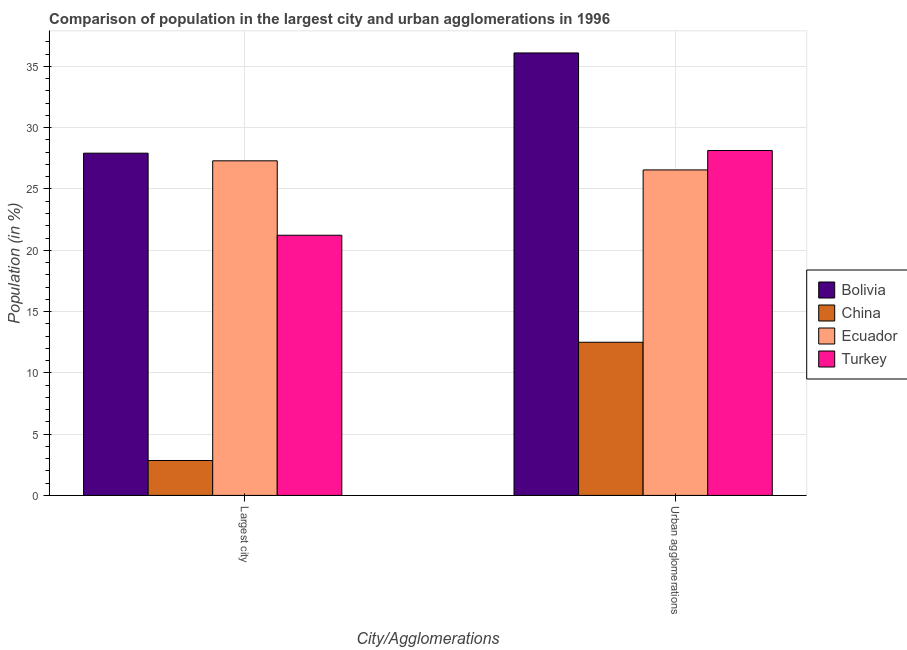How many different coloured bars are there?
Keep it short and to the point. 4. How many groups of bars are there?
Your answer should be very brief. 2. Are the number of bars on each tick of the X-axis equal?
Your answer should be very brief. Yes. How many bars are there on the 1st tick from the left?
Keep it short and to the point. 4. How many bars are there on the 1st tick from the right?
Offer a terse response. 4. What is the label of the 2nd group of bars from the left?
Your answer should be compact. Urban agglomerations. What is the population in urban agglomerations in Turkey?
Offer a terse response. 28.14. Across all countries, what is the maximum population in the largest city?
Offer a terse response. 27.92. Across all countries, what is the minimum population in urban agglomerations?
Your response must be concise. 12.5. What is the total population in the largest city in the graph?
Your answer should be compact. 79.3. What is the difference between the population in urban agglomerations in Ecuador and that in Bolivia?
Your answer should be compact. -9.54. What is the difference between the population in urban agglomerations in Bolivia and the population in the largest city in Ecuador?
Offer a very short reply. 8.8. What is the average population in urban agglomerations per country?
Your response must be concise. 25.82. What is the difference between the population in the largest city and population in urban agglomerations in Ecuador?
Your answer should be compact. 0.74. What is the ratio of the population in urban agglomerations in Turkey to that in Bolivia?
Give a very brief answer. 0.78. Is the population in the largest city in Turkey less than that in China?
Your answer should be very brief. No. What does the 1st bar from the left in Urban agglomerations represents?
Your answer should be compact. Bolivia. How many bars are there?
Offer a terse response. 8. How many countries are there in the graph?
Keep it short and to the point. 4. What is the difference between two consecutive major ticks on the Y-axis?
Give a very brief answer. 5. Does the graph contain any zero values?
Your answer should be compact. No. Does the graph contain grids?
Your response must be concise. Yes. How many legend labels are there?
Provide a short and direct response. 4. How are the legend labels stacked?
Provide a short and direct response. Vertical. What is the title of the graph?
Offer a very short reply. Comparison of population in the largest city and urban agglomerations in 1996. What is the label or title of the X-axis?
Offer a very short reply. City/Agglomerations. What is the label or title of the Y-axis?
Your response must be concise. Population (in %). What is the Population (in %) of Bolivia in Largest city?
Your answer should be very brief. 27.92. What is the Population (in %) in China in Largest city?
Offer a very short reply. 2.85. What is the Population (in %) in Ecuador in Largest city?
Ensure brevity in your answer.  27.3. What is the Population (in %) in Turkey in Largest city?
Make the answer very short. 21.23. What is the Population (in %) in Bolivia in Urban agglomerations?
Make the answer very short. 36.1. What is the Population (in %) of China in Urban agglomerations?
Offer a very short reply. 12.5. What is the Population (in %) in Ecuador in Urban agglomerations?
Keep it short and to the point. 26.56. What is the Population (in %) of Turkey in Urban agglomerations?
Your response must be concise. 28.14. Across all City/Agglomerations, what is the maximum Population (in %) in Bolivia?
Your answer should be compact. 36.1. Across all City/Agglomerations, what is the maximum Population (in %) in China?
Your answer should be compact. 12.5. Across all City/Agglomerations, what is the maximum Population (in %) in Ecuador?
Provide a short and direct response. 27.3. Across all City/Agglomerations, what is the maximum Population (in %) in Turkey?
Your answer should be very brief. 28.14. Across all City/Agglomerations, what is the minimum Population (in %) of Bolivia?
Your response must be concise. 27.92. Across all City/Agglomerations, what is the minimum Population (in %) in China?
Your response must be concise. 2.85. Across all City/Agglomerations, what is the minimum Population (in %) of Ecuador?
Your answer should be compact. 26.56. Across all City/Agglomerations, what is the minimum Population (in %) of Turkey?
Ensure brevity in your answer.  21.23. What is the total Population (in %) of Bolivia in the graph?
Offer a very short reply. 64.02. What is the total Population (in %) of China in the graph?
Provide a short and direct response. 15.35. What is the total Population (in %) in Ecuador in the graph?
Your answer should be compact. 53.85. What is the total Population (in %) in Turkey in the graph?
Offer a terse response. 49.37. What is the difference between the Population (in %) of Bolivia in Largest city and that in Urban agglomerations?
Make the answer very short. -8.18. What is the difference between the Population (in %) of China in Largest city and that in Urban agglomerations?
Offer a terse response. -9.65. What is the difference between the Population (in %) in Ecuador in Largest city and that in Urban agglomerations?
Provide a short and direct response. 0.74. What is the difference between the Population (in %) in Turkey in Largest city and that in Urban agglomerations?
Offer a very short reply. -6.91. What is the difference between the Population (in %) in Bolivia in Largest city and the Population (in %) in China in Urban agglomerations?
Make the answer very short. 15.43. What is the difference between the Population (in %) in Bolivia in Largest city and the Population (in %) in Ecuador in Urban agglomerations?
Keep it short and to the point. 1.37. What is the difference between the Population (in %) of Bolivia in Largest city and the Population (in %) of Turkey in Urban agglomerations?
Offer a very short reply. -0.22. What is the difference between the Population (in %) in China in Largest city and the Population (in %) in Ecuador in Urban agglomerations?
Offer a terse response. -23.71. What is the difference between the Population (in %) of China in Largest city and the Population (in %) of Turkey in Urban agglomerations?
Ensure brevity in your answer.  -25.29. What is the difference between the Population (in %) of Ecuador in Largest city and the Population (in %) of Turkey in Urban agglomerations?
Offer a terse response. -0.84. What is the average Population (in %) of Bolivia per City/Agglomerations?
Provide a succinct answer. 32.01. What is the average Population (in %) in China per City/Agglomerations?
Give a very brief answer. 7.67. What is the average Population (in %) in Ecuador per City/Agglomerations?
Keep it short and to the point. 26.93. What is the average Population (in %) in Turkey per City/Agglomerations?
Provide a short and direct response. 24.68. What is the difference between the Population (in %) in Bolivia and Population (in %) in China in Largest city?
Offer a terse response. 25.07. What is the difference between the Population (in %) of Bolivia and Population (in %) of Ecuador in Largest city?
Provide a short and direct response. 0.62. What is the difference between the Population (in %) of Bolivia and Population (in %) of Turkey in Largest city?
Keep it short and to the point. 6.7. What is the difference between the Population (in %) of China and Population (in %) of Ecuador in Largest city?
Give a very brief answer. -24.45. What is the difference between the Population (in %) in China and Population (in %) in Turkey in Largest city?
Offer a very short reply. -18.38. What is the difference between the Population (in %) in Ecuador and Population (in %) in Turkey in Largest city?
Your answer should be very brief. 6.07. What is the difference between the Population (in %) in Bolivia and Population (in %) in China in Urban agglomerations?
Your answer should be very brief. 23.6. What is the difference between the Population (in %) in Bolivia and Population (in %) in Ecuador in Urban agglomerations?
Ensure brevity in your answer.  9.54. What is the difference between the Population (in %) in Bolivia and Population (in %) in Turkey in Urban agglomerations?
Your answer should be compact. 7.96. What is the difference between the Population (in %) in China and Population (in %) in Ecuador in Urban agglomerations?
Offer a terse response. -14.06. What is the difference between the Population (in %) in China and Population (in %) in Turkey in Urban agglomerations?
Offer a terse response. -15.64. What is the difference between the Population (in %) in Ecuador and Population (in %) in Turkey in Urban agglomerations?
Keep it short and to the point. -1.58. What is the ratio of the Population (in %) of Bolivia in Largest city to that in Urban agglomerations?
Give a very brief answer. 0.77. What is the ratio of the Population (in %) in China in Largest city to that in Urban agglomerations?
Your answer should be very brief. 0.23. What is the ratio of the Population (in %) of Ecuador in Largest city to that in Urban agglomerations?
Provide a short and direct response. 1.03. What is the ratio of the Population (in %) of Turkey in Largest city to that in Urban agglomerations?
Offer a very short reply. 0.75. What is the difference between the highest and the second highest Population (in %) in Bolivia?
Give a very brief answer. 8.18. What is the difference between the highest and the second highest Population (in %) in China?
Your response must be concise. 9.65. What is the difference between the highest and the second highest Population (in %) of Ecuador?
Keep it short and to the point. 0.74. What is the difference between the highest and the second highest Population (in %) in Turkey?
Offer a very short reply. 6.91. What is the difference between the highest and the lowest Population (in %) in Bolivia?
Make the answer very short. 8.18. What is the difference between the highest and the lowest Population (in %) in China?
Give a very brief answer. 9.65. What is the difference between the highest and the lowest Population (in %) of Ecuador?
Ensure brevity in your answer.  0.74. What is the difference between the highest and the lowest Population (in %) of Turkey?
Your answer should be compact. 6.91. 